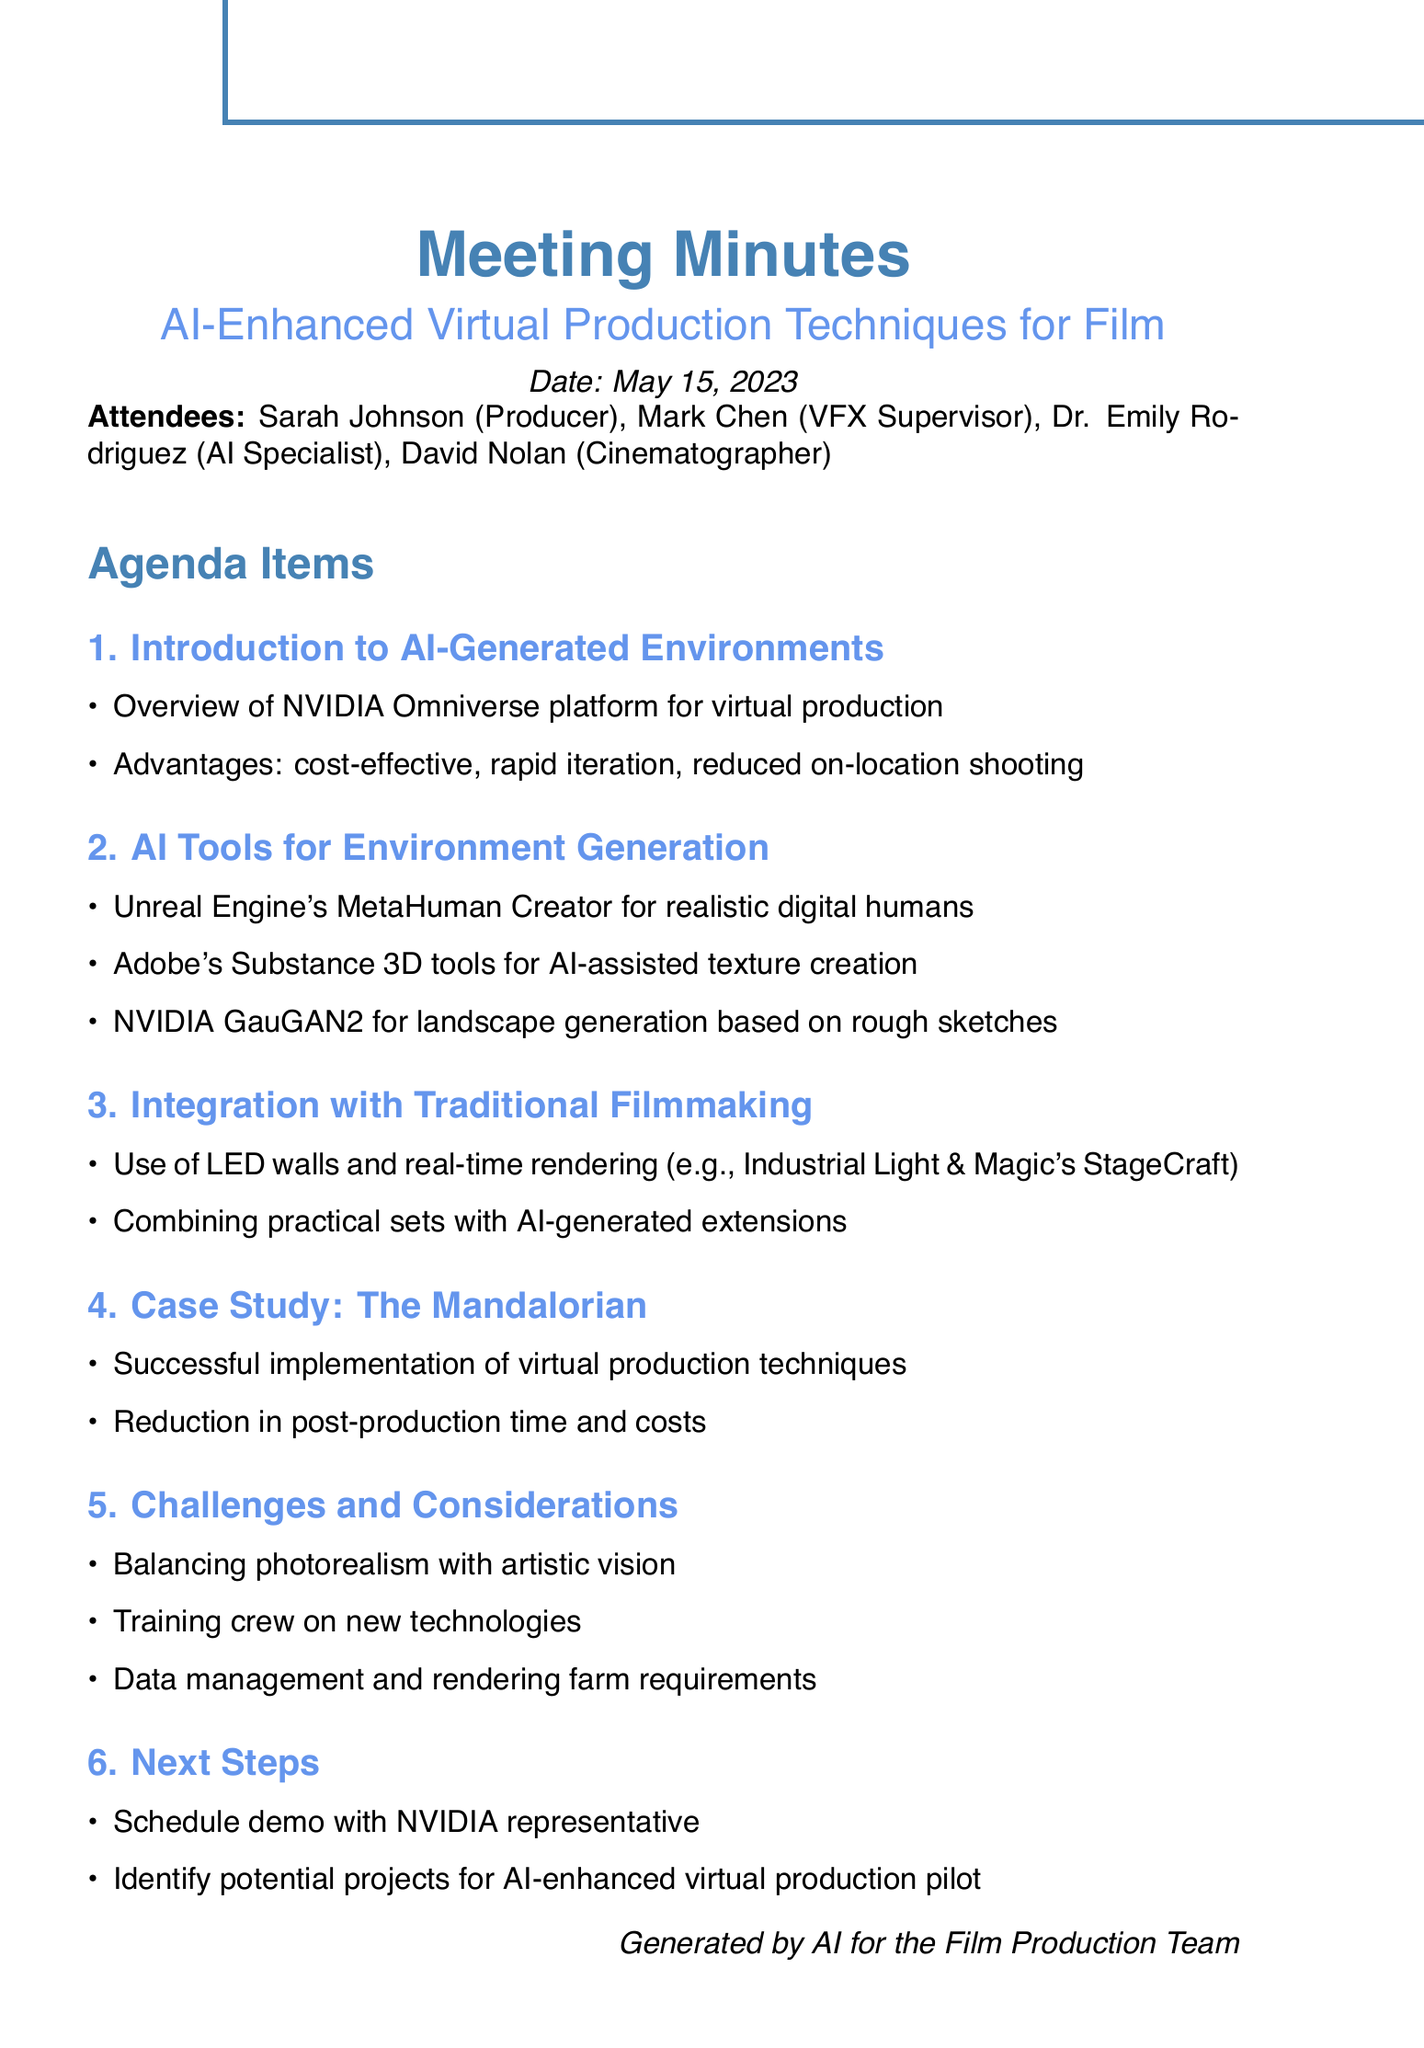What is the meeting date? The date of the meeting is mentioned explicitly in the document.
Answer: May 15, 2023 Who is the VFX Supervisor? The document lists the attendees, including their roles.
Answer: Mark Chen What platform is mentioned for virtual production? The agenda item provides information about AI-generated environments and the platform used.
Answer: NVIDIA Omniverse What is one of the advantages of using AI-generated environments? The advantages listed in the introduction highlight benefits of the technology discussed.
Answer: cost-effective Which AI tool is used for landscape generation? The section describes different AI tools and their purposes, specifically for landscape generation.
Answer: NVIDIA GauGAN2 What case study is referenced in the meeting? The document includes a case study that exemplifies the application of discussed techniques.
Answer: The Mandalorian What is one challenge mentioned regarding virtual production? The challenges and considerations section outlines specific difficulties encountered in the process.
Answer: balancing photorealism with artistic vision What is the next step suggested in the meeting? The next steps outline future actions to be taken after the meeting.
Answer: Schedule demo with NVIDIA representative How many attendees were present at the meeting? The list of attendees provides a count of individuals who participated.
Answer: Four 